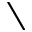<formula> <loc_0><loc_0><loc_500><loc_500>\</formula> 